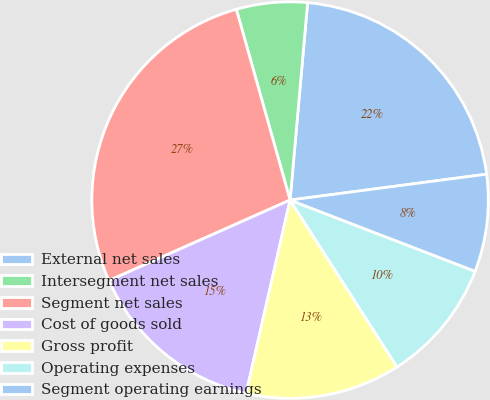<chart> <loc_0><loc_0><loc_500><loc_500><pie_chart><fcel>External net sales<fcel>Intersegment net sales<fcel>Segment net sales<fcel>Cost of goods sold<fcel>Gross profit<fcel>Operating expenses<fcel>Segment operating earnings<nl><fcel>21.5%<fcel>5.78%<fcel>27.28%<fcel>14.78%<fcel>12.63%<fcel>10.08%<fcel>7.93%<nl></chart> 